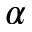<formula> <loc_0><loc_0><loc_500><loc_500>\alpha</formula> 